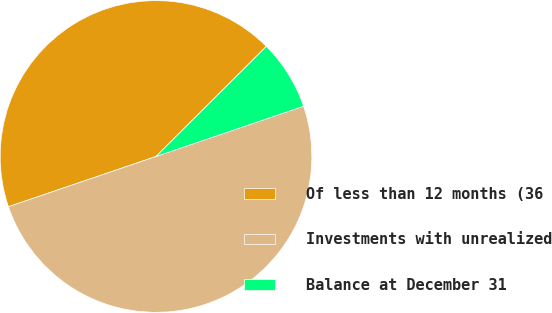Convert chart. <chart><loc_0><loc_0><loc_500><loc_500><pie_chart><fcel>Of less than 12 months (36<fcel>Investments with unrealized<fcel>Balance at December 31<nl><fcel>42.74%<fcel>50.0%<fcel>7.26%<nl></chart> 